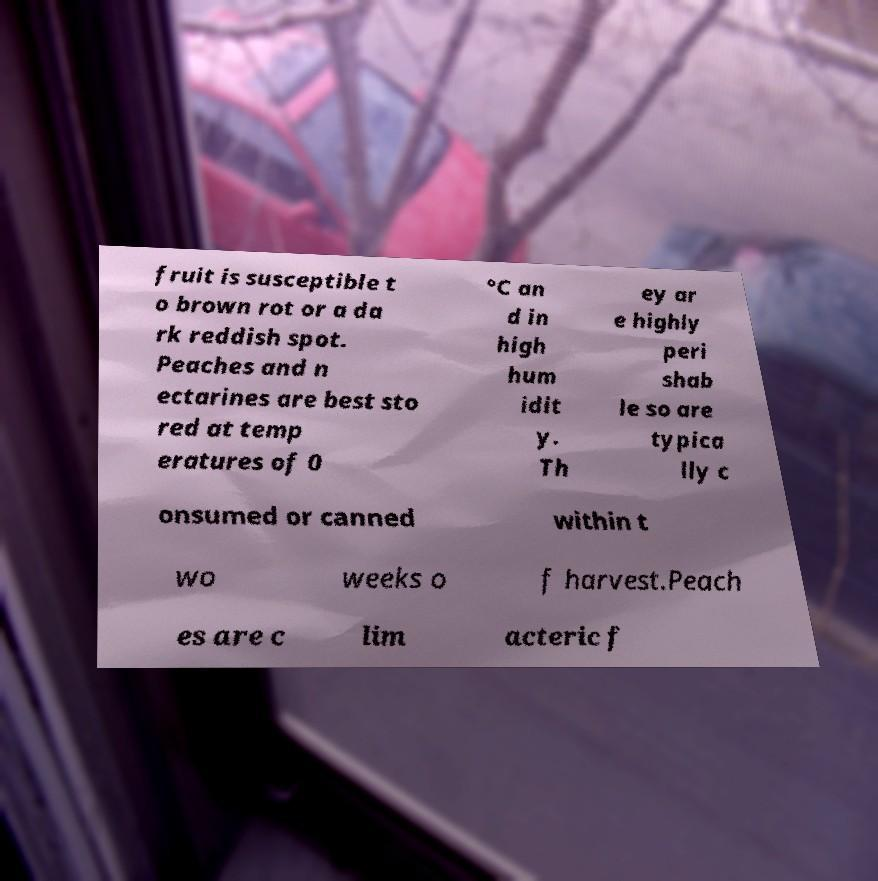Can you accurately transcribe the text from the provided image for me? fruit is susceptible t o brown rot or a da rk reddish spot. Peaches and n ectarines are best sto red at temp eratures of 0 °C an d in high hum idit y. Th ey ar e highly peri shab le so are typica lly c onsumed or canned within t wo weeks o f harvest.Peach es are c lim acteric f 